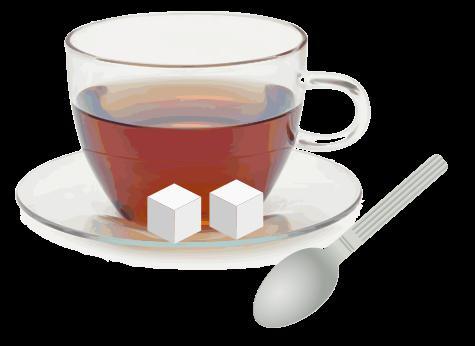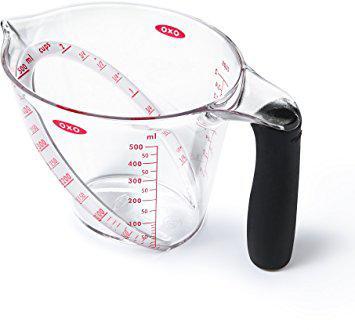The first image is the image on the left, the second image is the image on the right. Considering the images on both sides, is "A set of three clear measuring cups have red markings." valid? Answer yes or no. No. The first image is the image on the left, the second image is the image on the right. For the images displayed, is the sentence "The left image shows a set of measuring spoons" factually correct? Answer yes or no. No. 